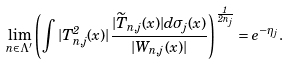Convert formula to latex. <formula><loc_0><loc_0><loc_500><loc_500>\lim _ { { n } \in \Lambda ^ { \prime } } \left ( \int | T _ { { n } , j } ^ { 2 } ( x ) | \frac { | \widetilde { T } _ { { n } , j } ( x ) | d \sigma _ { j } ( x ) } { | W _ { { n } , j } ( x ) | } \right ) ^ { \frac { 1 } { 2 n _ { j } } } = e ^ { - \eta _ { j } } .</formula> 